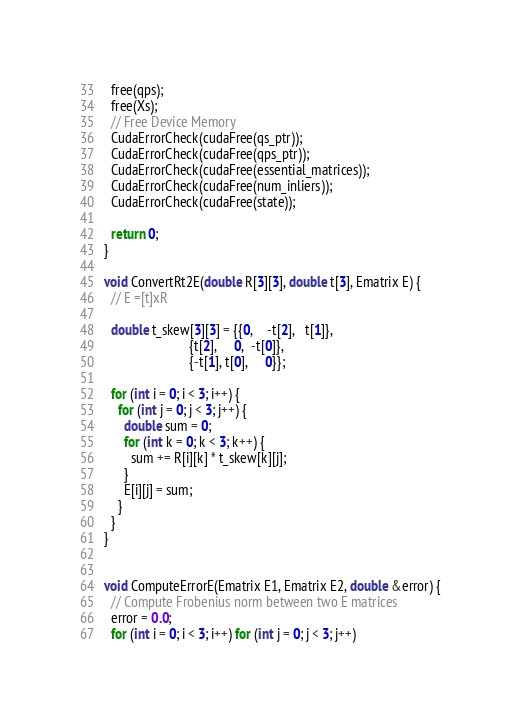<code> <loc_0><loc_0><loc_500><loc_500><_Cuda_>  free(qps);
  free(Xs);
  // Free Device Memory
  CudaErrorCheck(cudaFree(qs_ptr));
  CudaErrorCheck(cudaFree(qps_ptr));
  CudaErrorCheck(cudaFree(essential_matrices));
  CudaErrorCheck(cudaFree(num_inliers));
  CudaErrorCheck(cudaFree(state));
  
  return 0;
}

void ConvertRt2E(double R[3][3], double t[3], Ematrix E) {
  // E =[t]xR

  double t_skew[3][3] = {{0,    -t[2],   t[1]},
                         {t[2],     0,  -t[0]},
                         {-t[1], t[0],     0}};

  for (int i = 0; i < 3; i++) {
    for (int j = 0; j < 3; j++) {
      double sum = 0;
      for (int k = 0; k < 3; k++) {
        sum += R[i][k] * t_skew[k][j]; 
      }
      E[i][j] = sum;
    }
  }
}


void ComputeErrorE(Ematrix E1, Ematrix E2, double &error) {
  // Compute Frobenius norm between two E matrices
  error = 0.0;
  for (int i = 0; i < 3; i++) for (int j = 0; j < 3; j++)</code> 